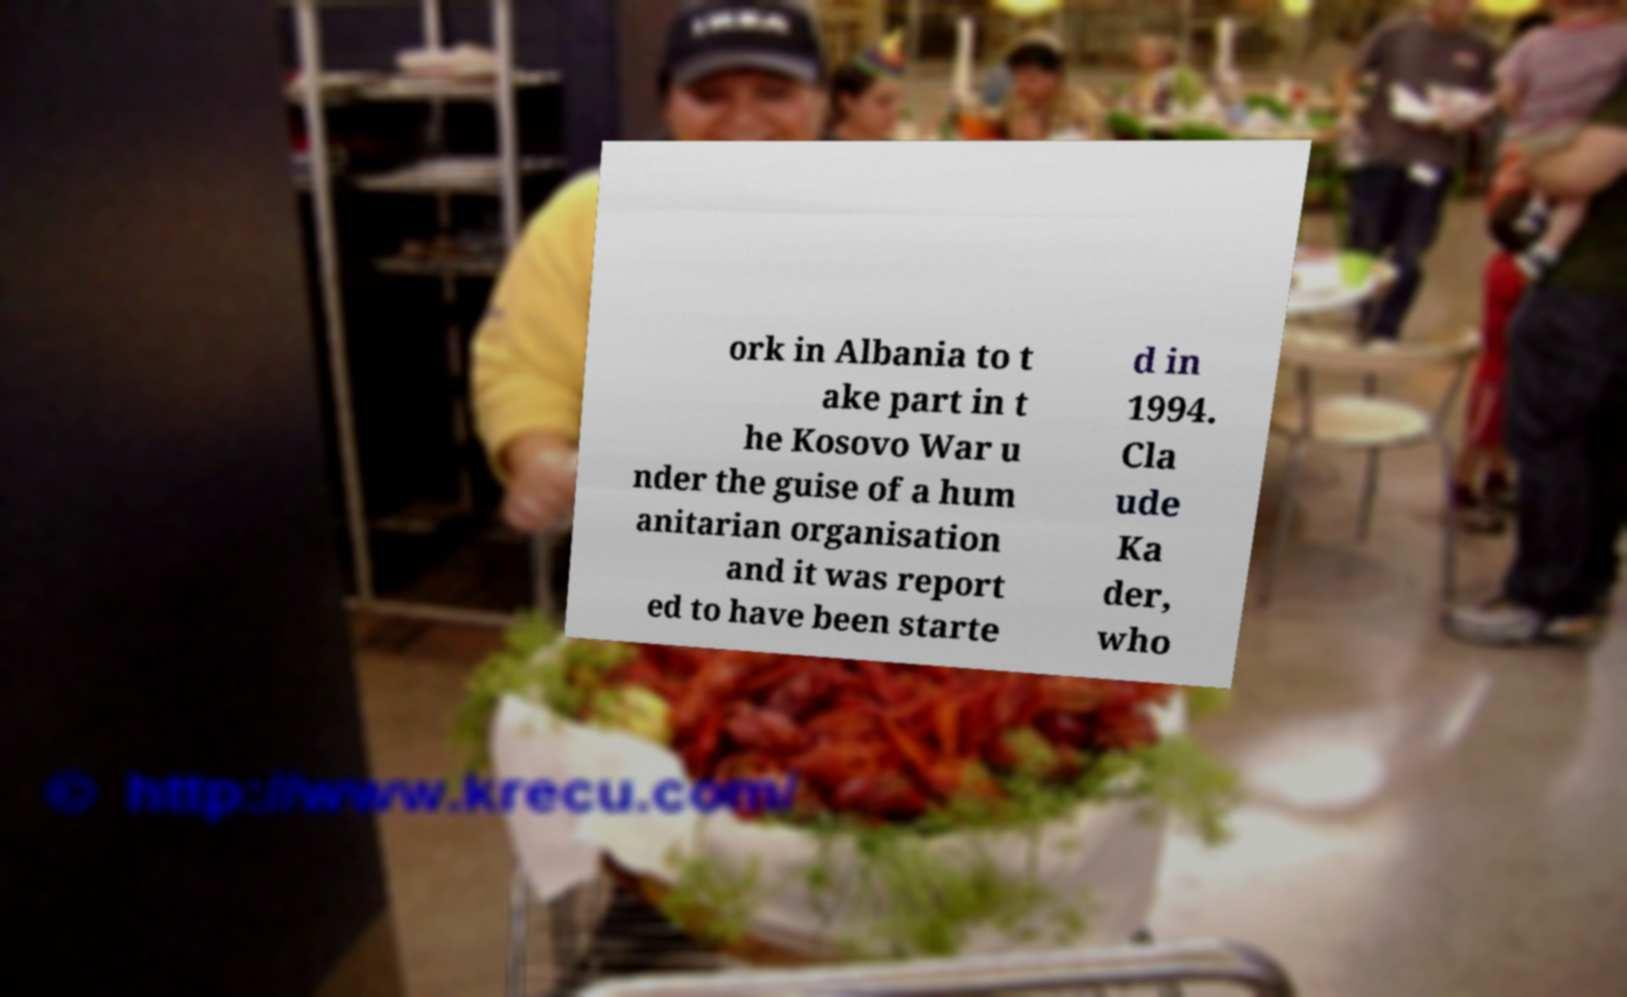There's text embedded in this image that I need extracted. Can you transcribe it verbatim? ork in Albania to t ake part in t he Kosovo War u nder the guise of a hum anitarian organisation and it was report ed to have been starte d in 1994. Cla ude Ka der, who 